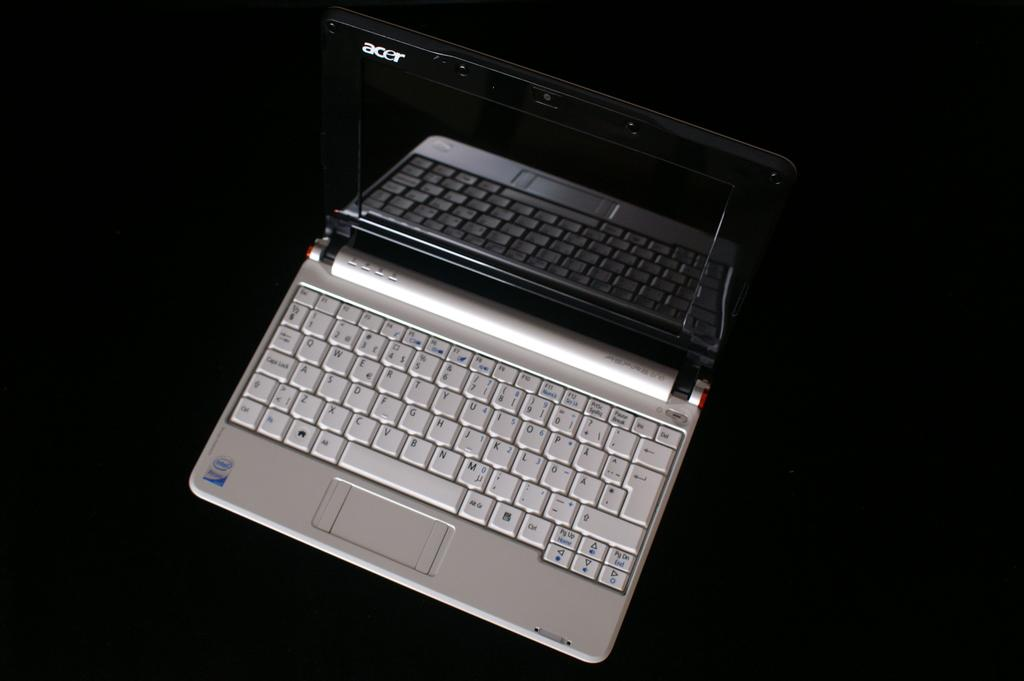<image>
Render a clear and concise summary of the photo. the laptop is open and is advertising Intel inside 